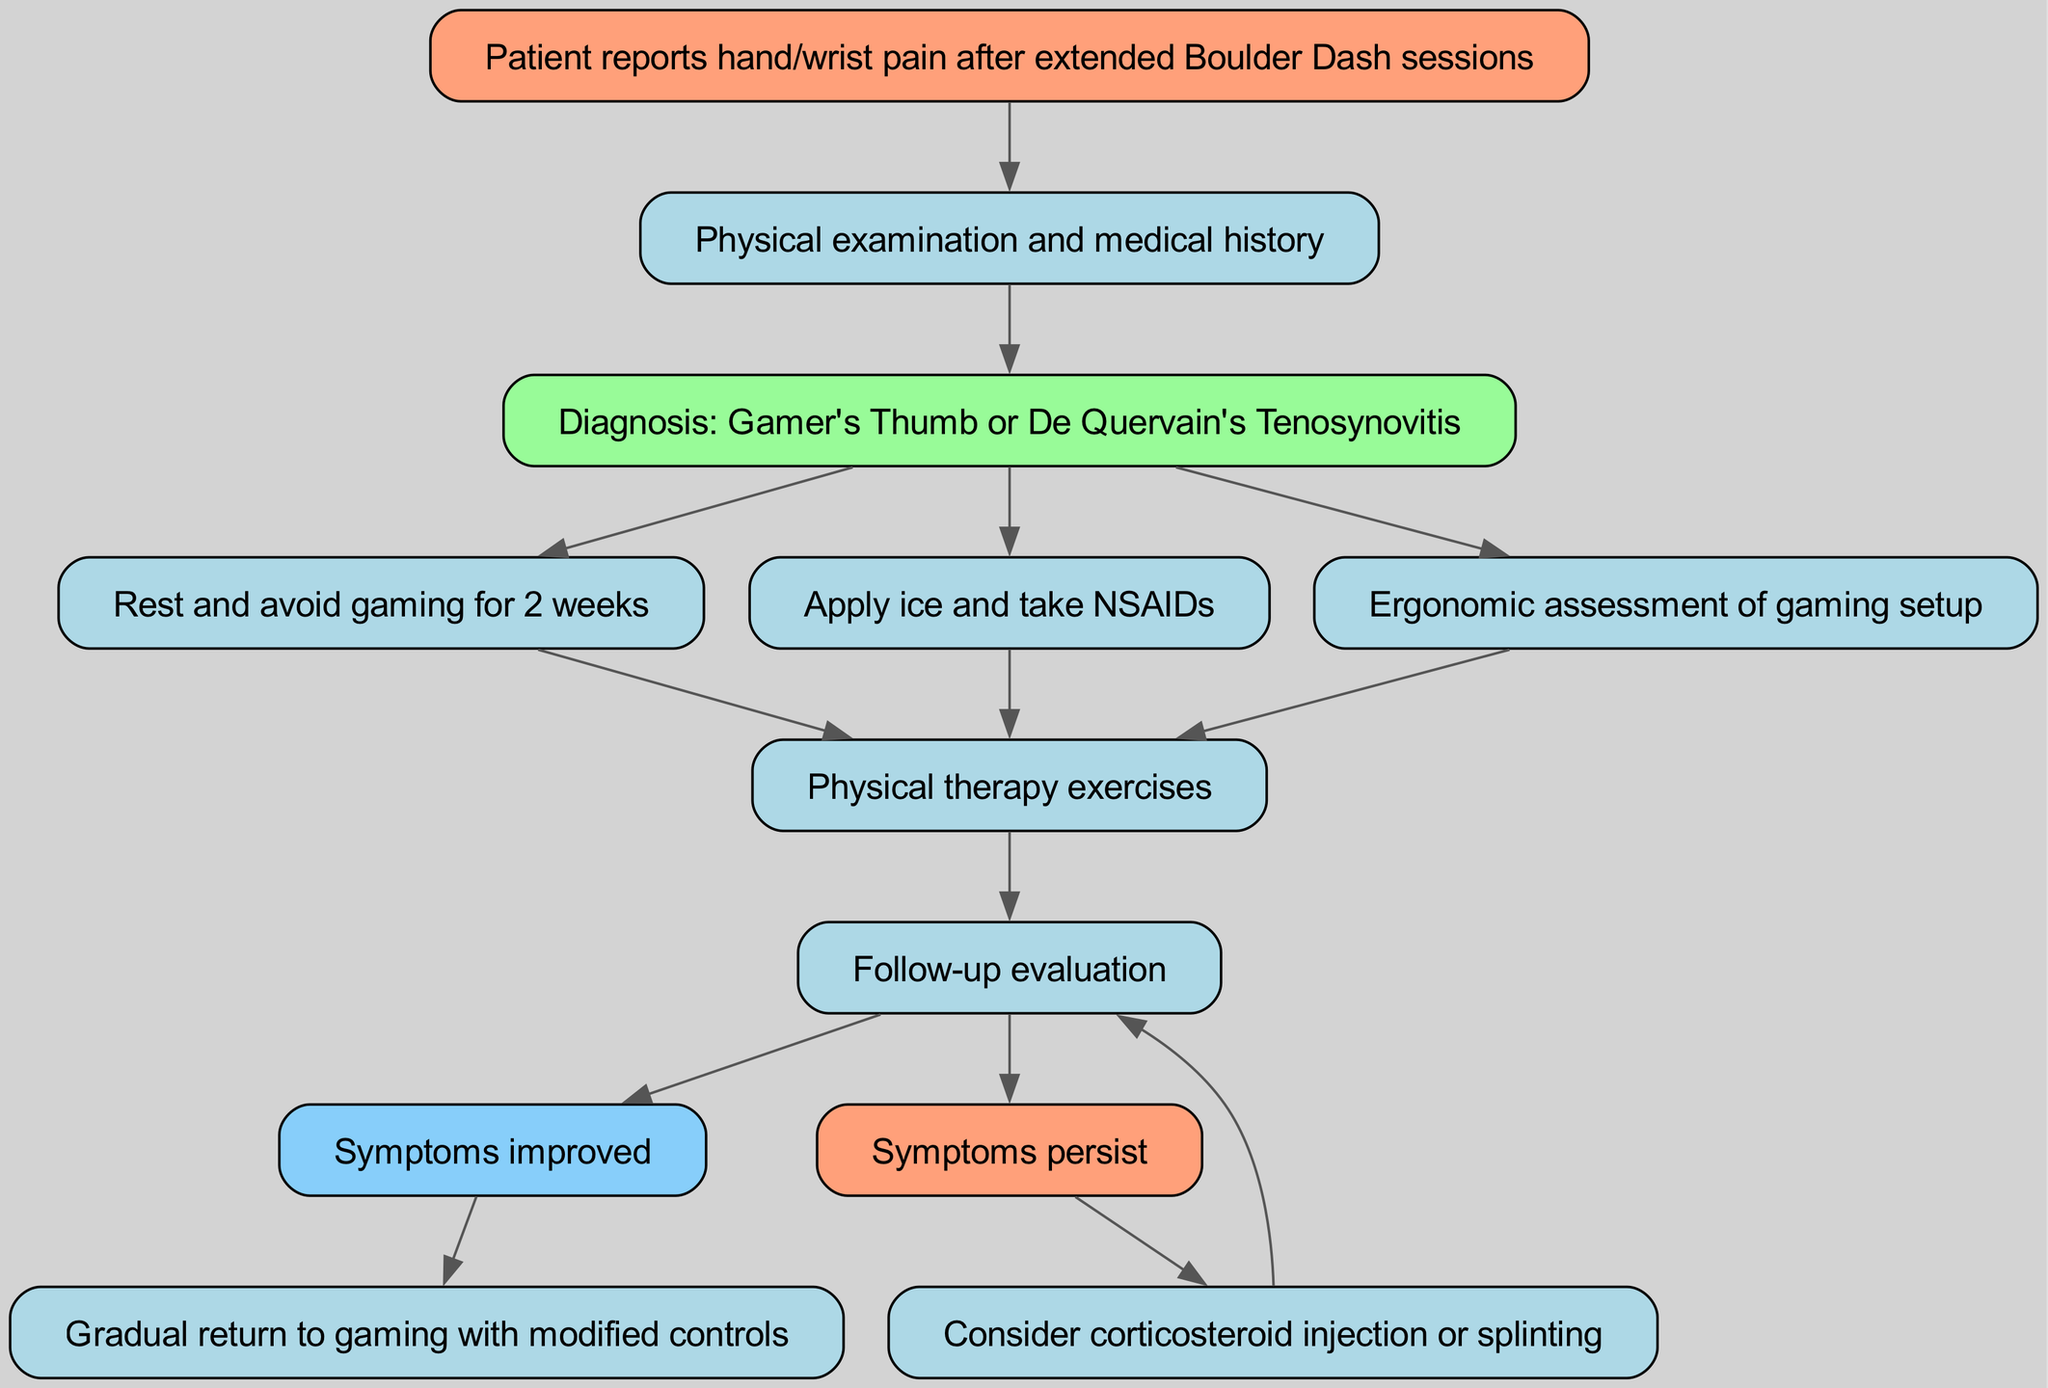What is the first node in the pathway? The first node is identified by its position in the diagram, which corresponds to the patient's initial report of pain. This is labeled as "Patient reports hand/wrist pain after extended Boulder Dash sessions."
Answer: Patient reports hand/wrist pain after extended Boulder Dash sessions What diagnosis is made in the pathway? By following the arrows from the physical examination and medical history (node 2), we reach the diagnosis node which states, "Diagnosis: Gamer's Thumb or De Quervain's Tenosynovitis."
Answer: Diagnosis: Gamer's Thumb or De Quervain's Tenosynovitis How many treatment options are listed after the diagnosis? The edges stemming from the diagnosis node indicate three distinct treatment options: rest, apply ice and take NSAIDs, and ergonomic assessment, leading to a total of three options.
Answer: 3 What happens after physical therapy exercises? After the physical therapy exercises noted in node 7, the pathway leads to a follow-up evaluation (node 8), which assesses the patient's condition.
Answer: Follow-up evaluation What is the outcome if symptoms improve after the follow-up evaluation? If symptoms improve after the follow-up evaluation (node 8), the pathway indicates a move to node 9, which describes that the symptoms improved, leading to a recommendation for a gradual return to gaming.
Answer: Symptoms improved What intervention is considered if symptoms persist after the follow-up? If the follow-up evaluation shows persistent symptoms, the pathway directs to node 12 where it suggests considering corticosteroid injection or splinting as further intervention.
Answer: Consider corticosteroid injection or splinting Which node represents the rest period after diagnosis? The node connected directly from the diagnosis node (node 3) to indicate treatment measures is node 4, which states, "Rest and avoid gaming for 2 weeks."
Answer: Rest and avoid gaming for 2 weeks What type of diagram is this? The structure and flow of the diagram clearly indicate it's a clinical pathway, showcasing diagnosis and treatment steps for specific injuries, particularly those related to gaming.
Answer: Clinical Pathway 